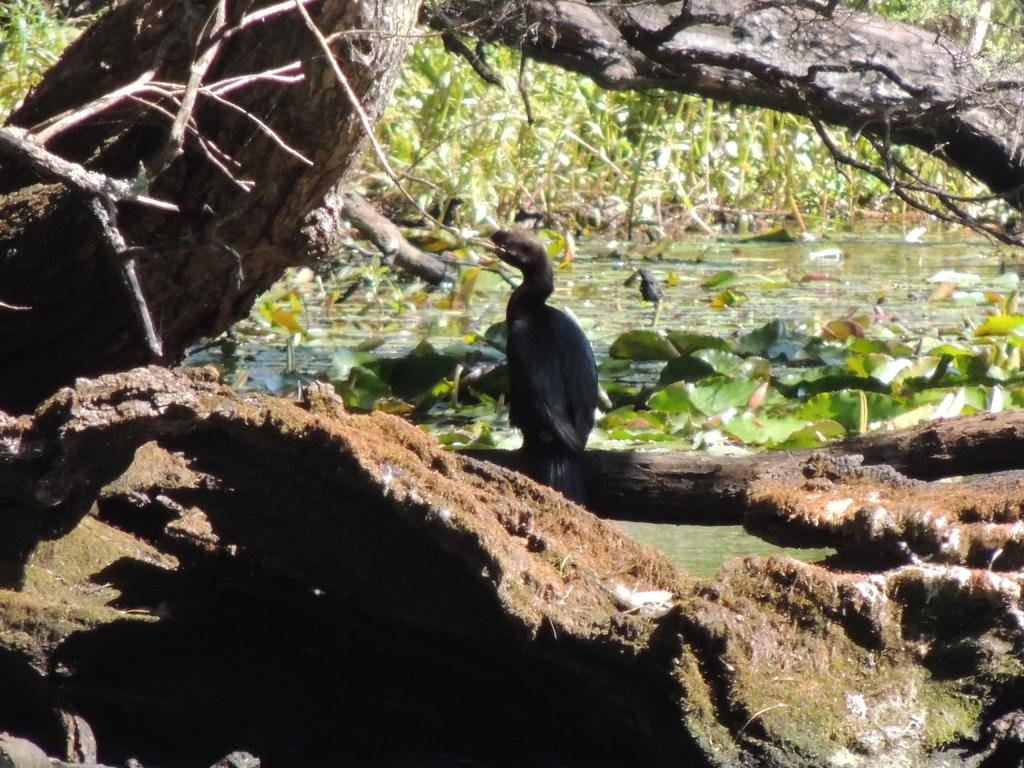What type of plant can be seen in the image? There is a tree in the image. Is there any wildlife present in the image? Yes, there is a bird on a branch of the tree. What can be seen in the background of the image? There is water visible in the image. What other types of plants can be seen in the image? There are plants in the image. What type of dress is the bird wearing in the image? There is no dress present in the image, as birds do not wear clothing. 